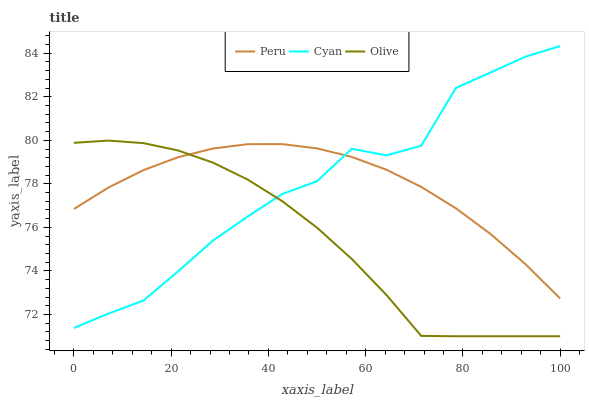Does Olive have the minimum area under the curve?
Answer yes or no. Yes. Does Cyan have the maximum area under the curve?
Answer yes or no. Yes. Does Peru have the minimum area under the curve?
Answer yes or no. No. Does Peru have the maximum area under the curve?
Answer yes or no. No. Is Peru the smoothest?
Answer yes or no. Yes. Is Cyan the roughest?
Answer yes or no. Yes. Is Cyan the smoothest?
Answer yes or no. No. Is Peru the roughest?
Answer yes or no. No. Does Olive have the lowest value?
Answer yes or no. Yes. Does Cyan have the lowest value?
Answer yes or no. No. Does Cyan have the highest value?
Answer yes or no. Yes. Does Peru have the highest value?
Answer yes or no. No. Does Peru intersect Olive?
Answer yes or no. Yes. Is Peru less than Olive?
Answer yes or no. No. Is Peru greater than Olive?
Answer yes or no. No. 